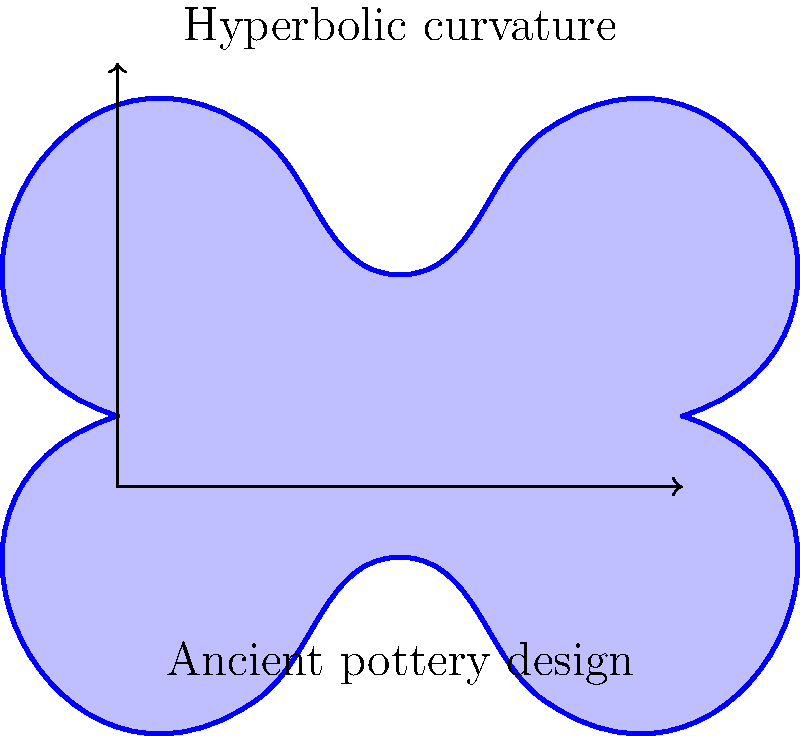In designing an ancient pottery artifact for a historical film, you want to incorporate hyperbolic curvature. The image shows a cross-section of a pottery design with hyperbolic curvature. How would you describe the key characteristic of this hyperbolic curve that distinguishes it from a regular circular curve? To understand the key characteristic of hyperbolic curvature in this pottery design, let's follow these steps:

1. Observe the curve shape: The curve bends inward, creating a saddle-like shape.

2. Compare to circular curve: A circular curve would maintain a constant curvature throughout.

3. Analyze curvature changes: In this hyperbolic curve, the curvature changes along the curve.

4. Identify the distinguishing feature: The most notable characteristic is that the curve has negative curvature.

5. Understand negative curvature: This means that the center of curvature lies on the opposite side of the curve compared to a circle.

6. Visualize in 3D: If extended into three dimensions, this curve would create a shape that curves inward in one direction and outward in the perpendicular direction.

7. Relate to ancient pottery: This type of curve could be used to create unique, mathematically-inspired designs on ancient pottery, giving it a distinctive and intriguing appearance.

The key characteristic that distinguishes this hyperbolic curve from a regular circular curve is its negative curvature, which creates a saddle-like shape.
Answer: Negative curvature 